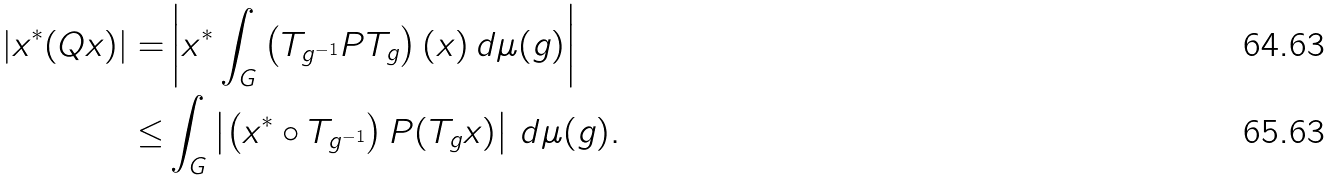<formula> <loc_0><loc_0><loc_500><loc_500>| x ^ { * } ( Q x ) | = & \left | x ^ { * } \int _ { G } \left ( T _ { g ^ { - 1 } } P T _ { g } \right ) ( x ) \, d \mu ( g ) \right | \\ \leq & \int _ { G } \left | \left ( x ^ { * } \circ T _ { g ^ { - 1 } } \right ) P ( T _ { g } x ) \right | \, d \mu ( g ) .</formula> 